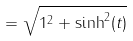Convert formula to latex. <formula><loc_0><loc_0><loc_500><loc_500>= \sqrt { 1 ^ { 2 } + \sinh ^ { 2 } ( t ) }</formula> 